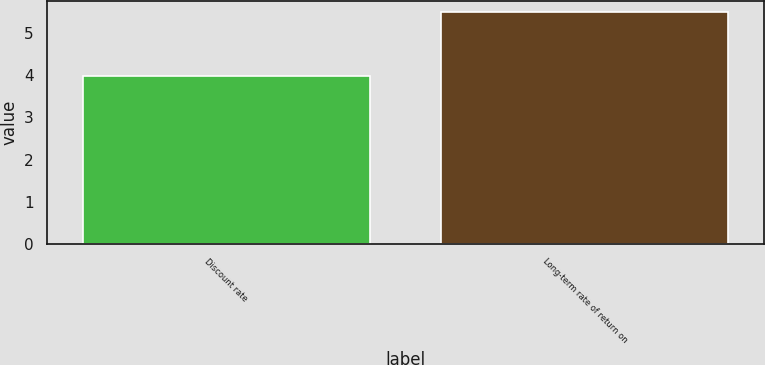<chart> <loc_0><loc_0><loc_500><loc_500><bar_chart><fcel>Discount rate<fcel>Long-term rate of return on<nl><fcel>3.99<fcel>5.5<nl></chart> 